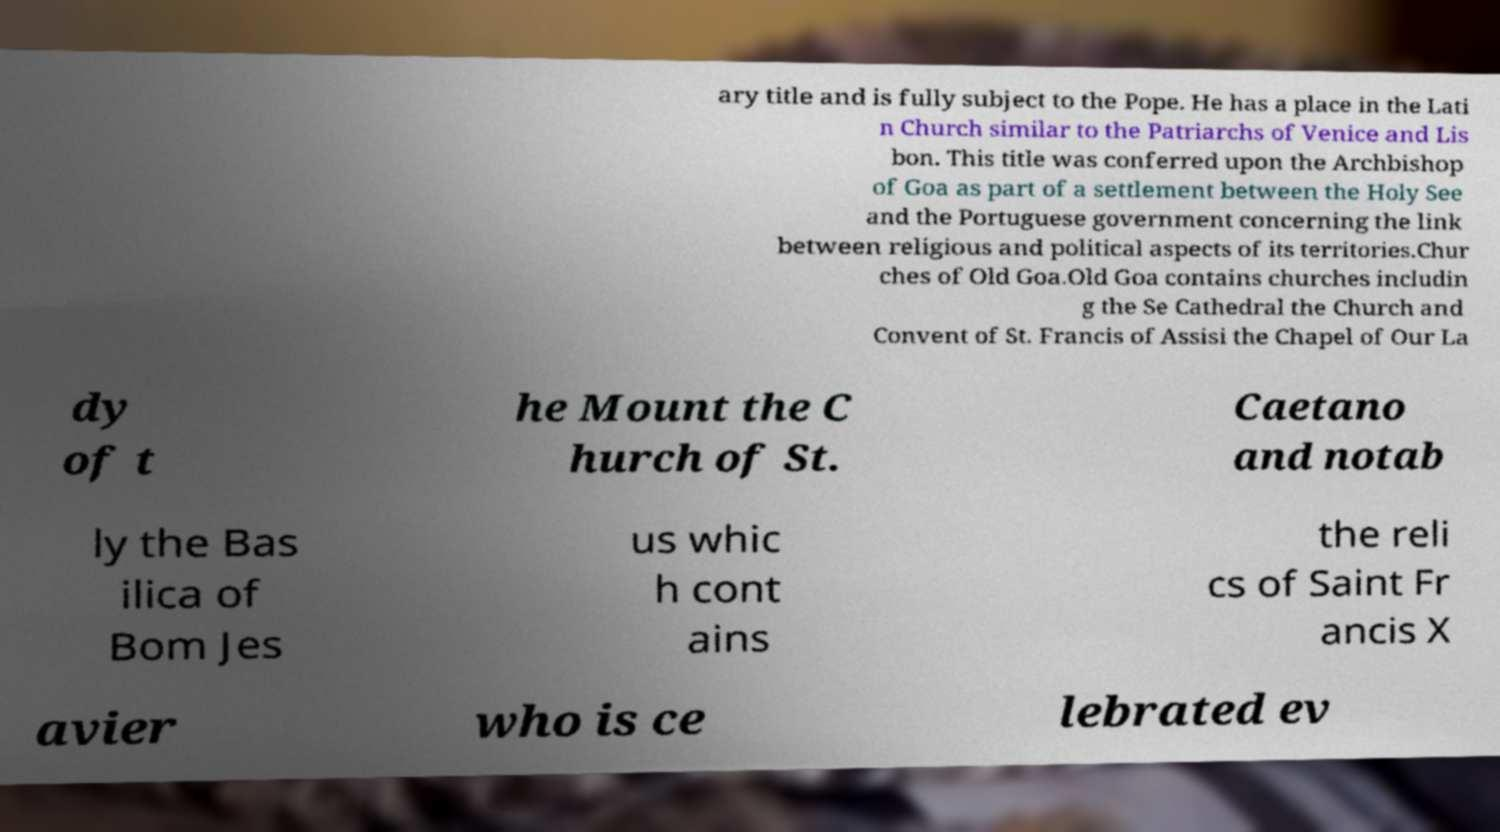I need the written content from this picture converted into text. Can you do that? ary title and is fully subject to the Pope. He has a place in the Lati n Church similar to the Patriarchs of Venice and Lis bon. This title was conferred upon the Archbishop of Goa as part of a settlement between the Holy See and the Portuguese government concerning the link between religious and political aspects of its territories.Chur ches of Old Goa.Old Goa contains churches includin g the Se Cathedral the Church and Convent of St. Francis of Assisi the Chapel of Our La dy of t he Mount the C hurch of St. Caetano and notab ly the Bas ilica of Bom Jes us whic h cont ains the reli cs of Saint Fr ancis X avier who is ce lebrated ev 